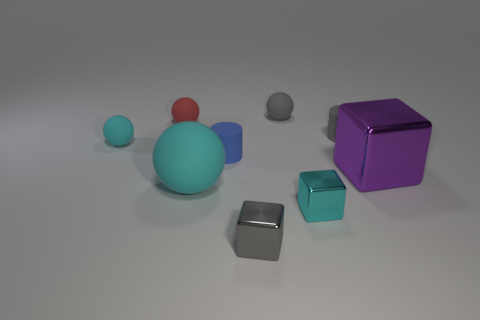How many other objects are there of the same size as the blue cylinder?
Make the answer very short. 6. There is a gray rubber thing behind the tiny red ball; what is its size?
Offer a terse response. Small. There is a big object that is the same material as the tiny blue object; what shape is it?
Keep it short and to the point. Sphere. Is there anything else that is the same color as the big block?
Your answer should be very brief. No. The matte cylinder behind the cyan ball that is to the left of the large cyan sphere is what color?
Provide a succinct answer. Gray. What number of small things are either cyan rubber spheres or red rubber balls?
Give a very brief answer. 2. What material is the gray thing that is the same shape as the big purple object?
Keep it short and to the point. Metal. The large shiny cube has what color?
Ensure brevity in your answer.  Purple. What number of large metal blocks are right of the small cyan thing that is to the right of the small gray shiny thing?
Make the answer very short. 1. What size is the thing that is in front of the small blue cylinder and behind the large rubber thing?
Provide a short and direct response. Large. 